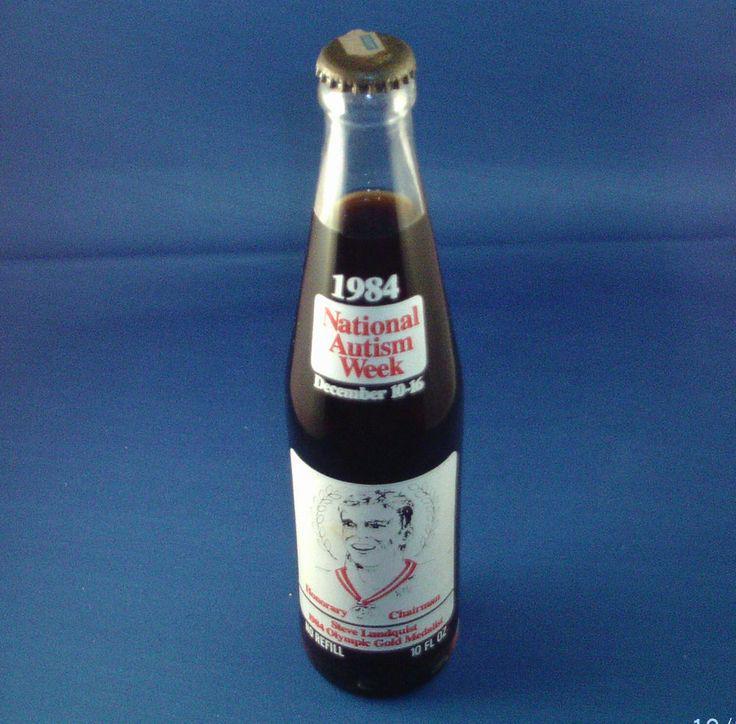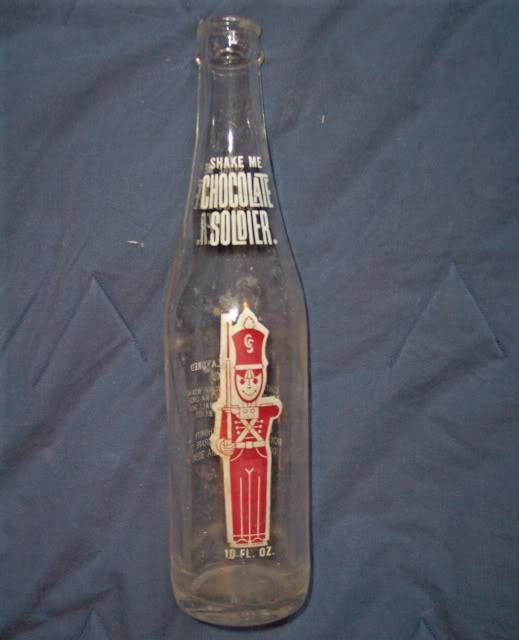The first image is the image on the left, the second image is the image on the right. Analyze the images presented: Is the assertion "Each image shows a single glass bottle, at least one of the pictured bottles is empty, and at least one bottle has a red 'toy soldier' depicted on the front." valid? Answer yes or no. Yes. The first image is the image on the left, the second image is the image on the right. Analyze the images presented: Is the assertion "The right image contains exactly three bottles." valid? Answer yes or no. No. 